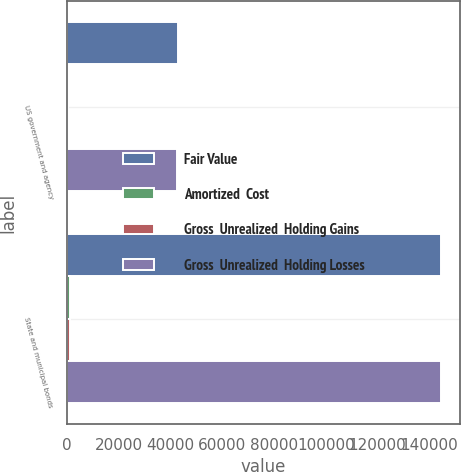Convert chart. <chart><loc_0><loc_0><loc_500><loc_500><stacked_bar_chart><ecel><fcel>US government and agency<fcel>State and municipal bonds<nl><fcel>Fair Value<fcel>42842<fcel>144528<nl><fcel>Amortized  Cost<fcel>30<fcel>1366<nl><fcel>Gross  Unrealized  Holding Gains<fcel>338<fcel>1356<nl><fcel>Gross  Unrealized  Holding Losses<fcel>42534<fcel>144538<nl></chart> 